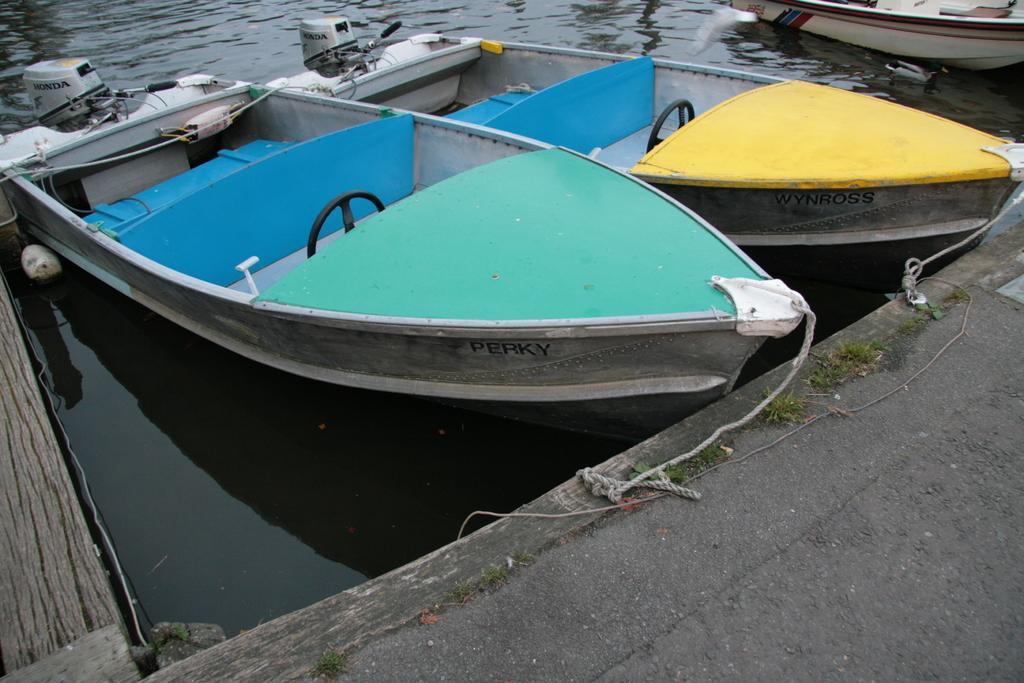In one or two sentences, can you explain what this image depicts? In this picture we can see a few boats on the water. There are ropes, some grass and wooden objects. 